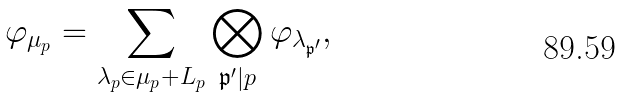<formula> <loc_0><loc_0><loc_500><loc_500>\varphi _ { \mu _ { p } } = \sum _ { \lambda _ { p } \in \mu _ { p } + L _ { p } } \bigotimes _ { \mathfrak { p } ^ { \prime } | p } \varphi _ { \lambda _ { \mathfrak { p } ^ { \prime } } } ,</formula> 